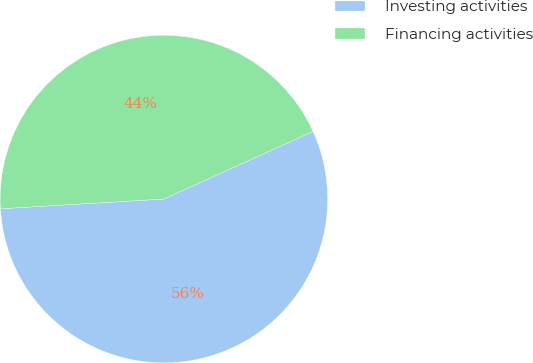<chart> <loc_0><loc_0><loc_500><loc_500><pie_chart><fcel>Investing activities<fcel>Financing activities<nl><fcel>55.83%<fcel>44.17%<nl></chart> 